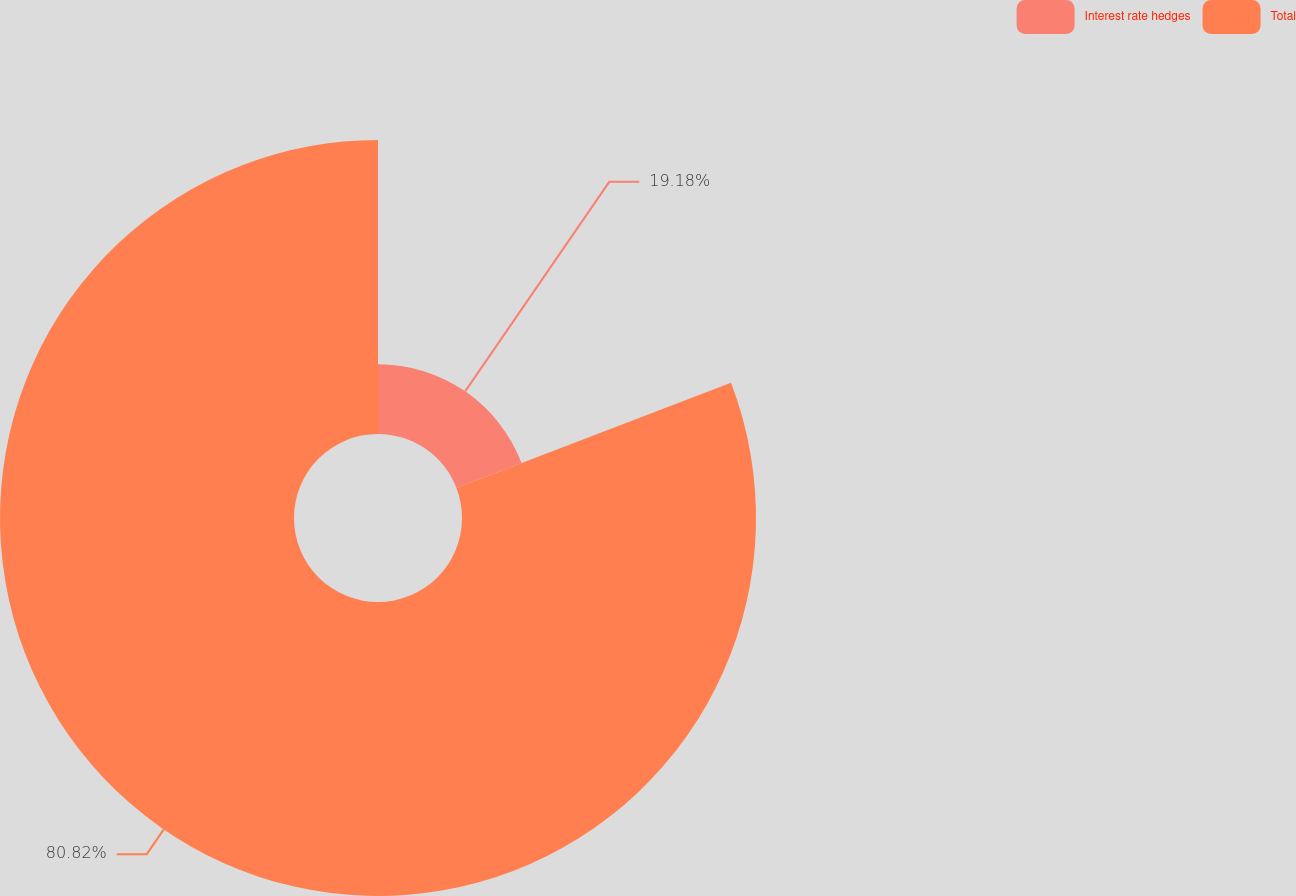<chart> <loc_0><loc_0><loc_500><loc_500><pie_chart><fcel>Interest rate hedges<fcel>Total<nl><fcel>19.18%<fcel>80.82%<nl></chart> 